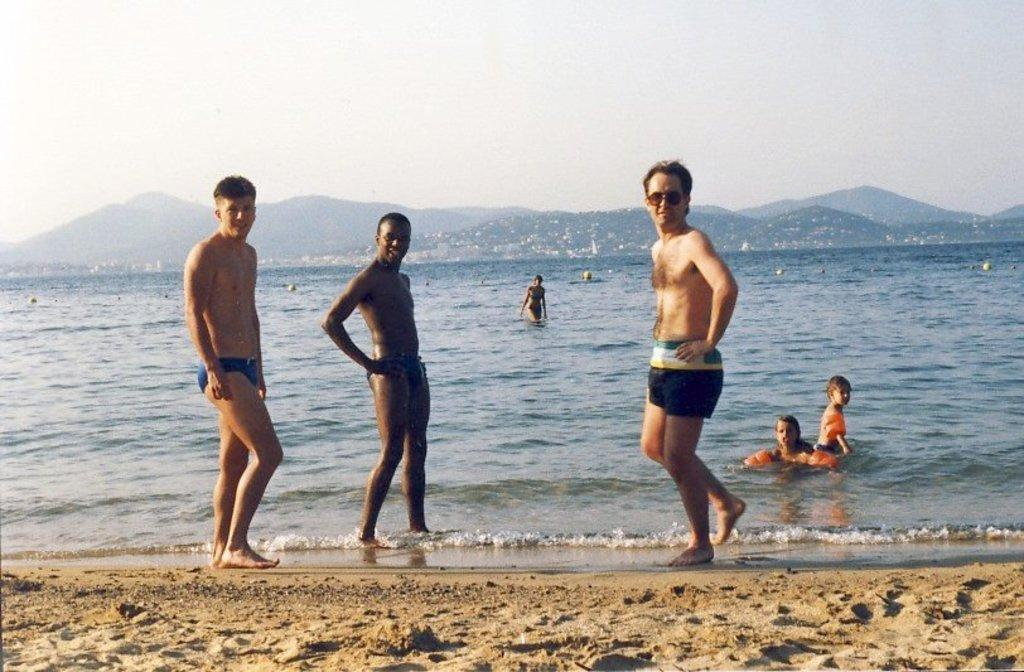How many men are standing on the sand in the image? There are three men standing on the sand in the image. What are the people in the background doing? The people in the background are swimming in the water. What type of landscape can be seen in the background? Hills are visible in the background. What is the condition of the sky in the image? The sky is plain in the background. Where is the clover growing in the image? There is no clover present in the image. What type of tub is visible in the image? There is no tub present in the image. 